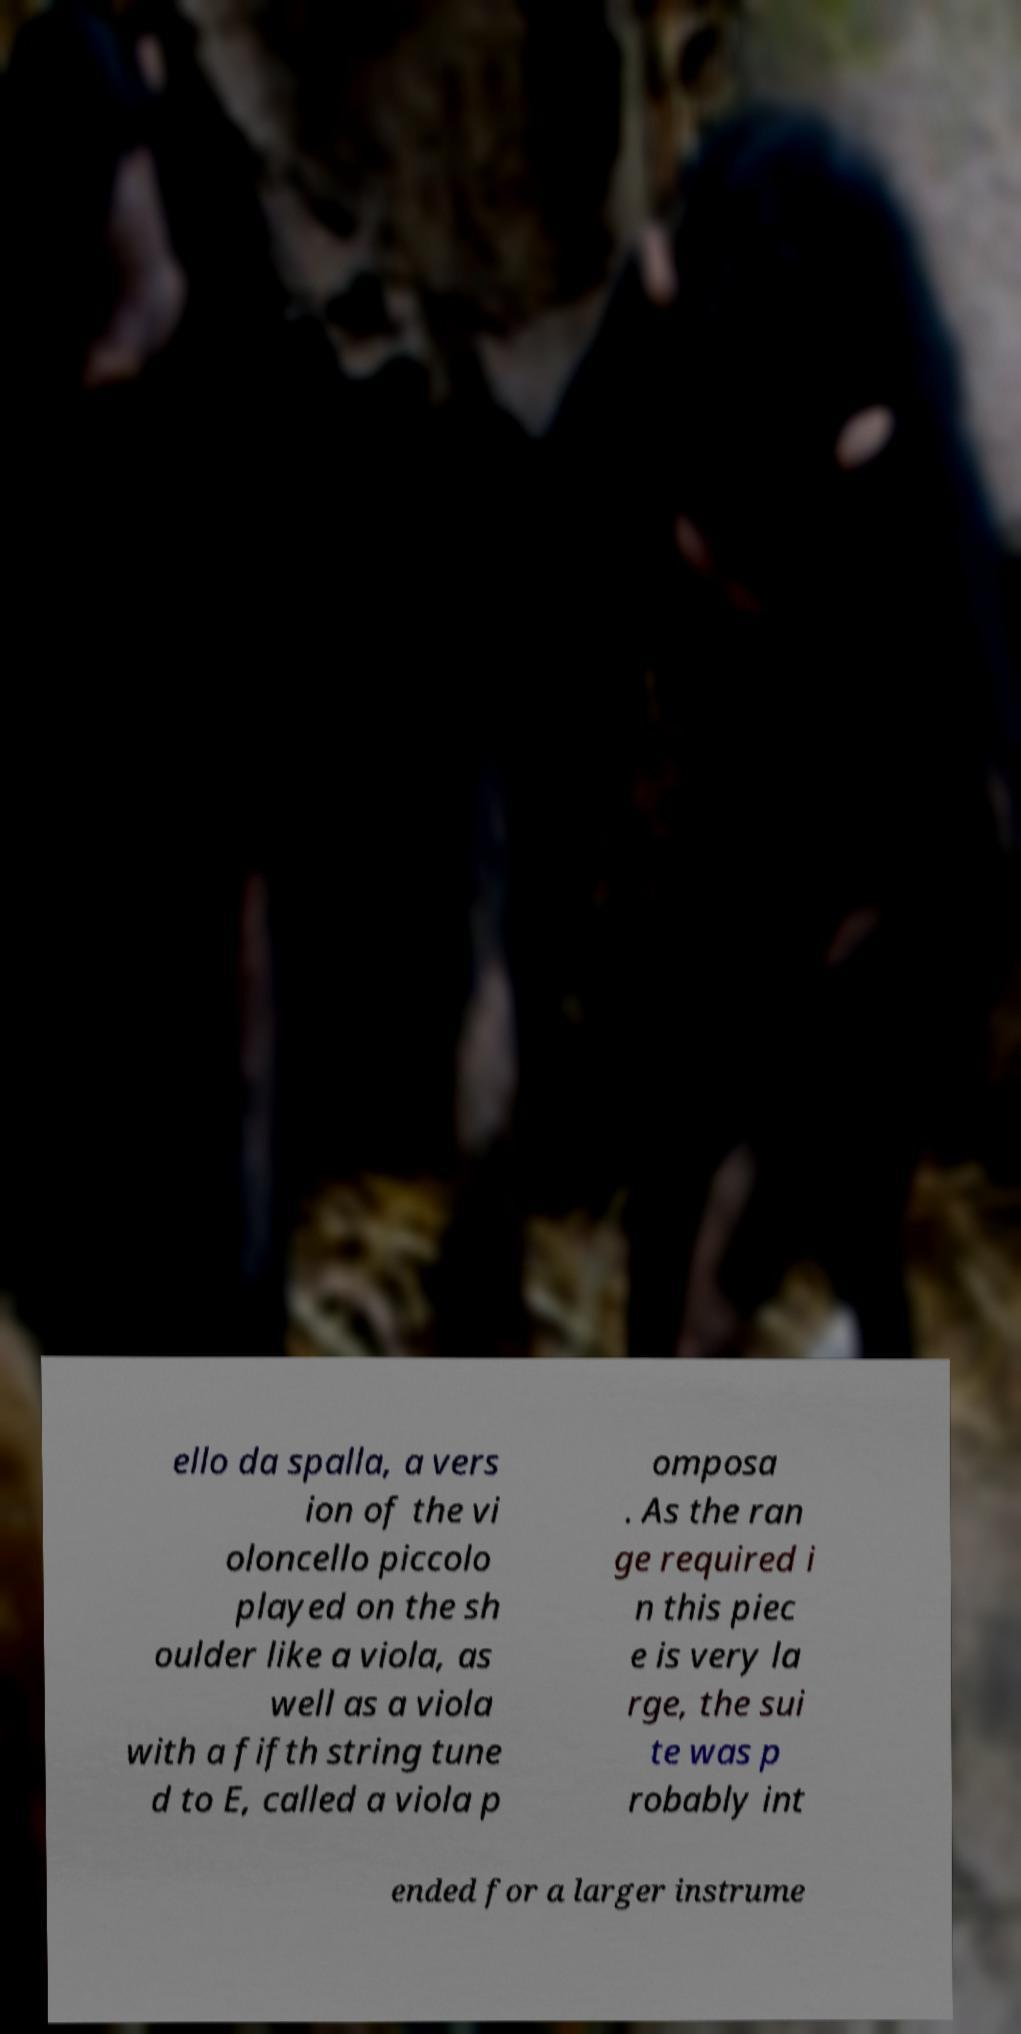For documentation purposes, I need the text within this image transcribed. Could you provide that? ello da spalla, a vers ion of the vi oloncello piccolo played on the sh oulder like a viola, as well as a viola with a fifth string tune d to E, called a viola p omposa . As the ran ge required i n this piec e is very la rge, the sui te was p robably int ended for a larger instrume 